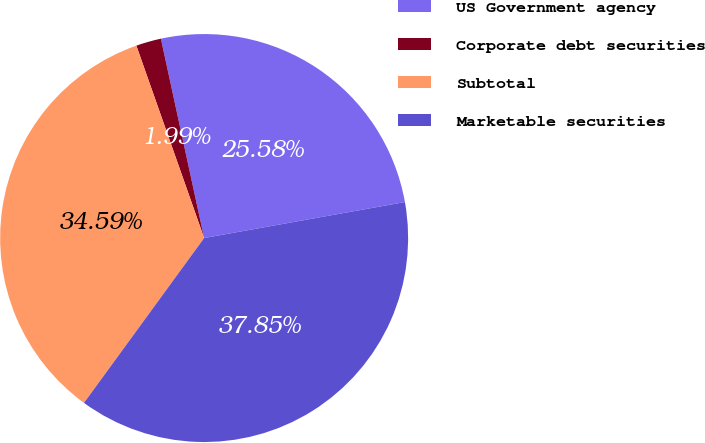Convert chart to OTSL. <chart><loc_0><loc_0><loc_500><loc_500><pie_chart><fcel>US Government agency<fcel>Corporate debt securities<fcel>Subtotal<fcel>Marketable securities<nl><fcel>25.58%<fcel>1.99%<fcel>34.59%<fcel>37.85%<nl></chart> 